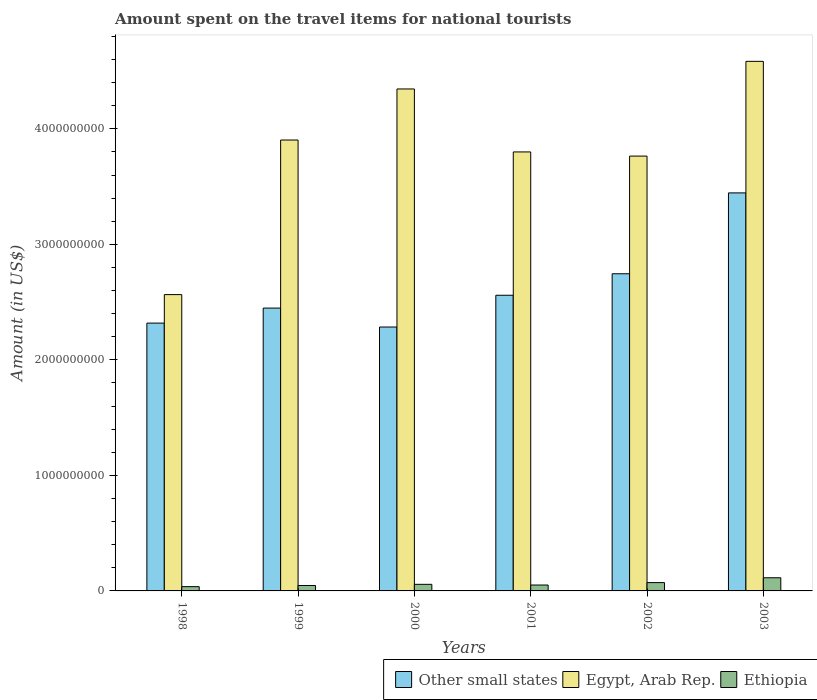Are the number of bars per tick equal to the number of legend labels?
Make the answer very short. Yes. Are the number of bars on each tick of the X-axis equal?
Offer a very short reply. Yes. How many bars are there on the 2nd tick from the left?
Ensure brevity in your answer.  3. How many bars are there on the 4th tick from the right?
Ensure brevity in your answer.  3. In how many cases, is the number of bars for a given year not equal to the number of legend labels?
Keep it short and to the point. 0. What is the amount spent on the travel items for national tourists in Egypt, Arab Rep. in 2001?
Provide a succinct answer. 3.80e+09. Across all years, what is the maximum amount spent on the travel items for national tourists in Other small states?
Your response must be concise. 3.45e+09. Across all years, what is the minimum amount spent on the travel items for national tourists in Other small states?
Your response must be concise. 2.28e+09. In which year was the amount spent on the travel items for national tourists in Ethiopia maximum?
Provide a short and direct response. 2003. In which year was the amount spent on the travel items for national tourists in Other small states minimum?
Your answer should be compact. 2000. What is the total amount spent on the travel items for national tourists in Other small states in the graph?
Keep it short and to the point. 1.58e+1. What is the difference between the amount spent on the travel items for national tourists in Ethiopia in 1999 and that in 2000?
Your answer should be compact. -1.00e+07. What is the difference between the amount spent on the travel items for national tourists in Ethiopia in 2000 and the amount spent on the travel items for national tourists in Egypt, Arab Rep. in 2002?
Keep it short and to the point. -3.71e+09. What is the average amount spent on the travel items for national tourists in Other small states per year?
Give a very brief answer. 2.63e+09. In the year 2003, what is the difference between the amount spent on the travel items for national tourists in Ethiopia and amount spent on the travel items for national tourists in Other small states?
Your answer should be compact. -3.33e+09. What is the ratio of the amount spent on the travel items for national tourists in Other small states in 2000 to that in 2003?
Provide a succinct answer. 0.66. Is the difference between the amount spent on the travel items for national tourists in Ethiopia in 1998 and 2002 greater than the difference between the amount spent on the travel items for national tourists in Other small states in 1998 and 2002?
Give a very brief answer. Yes. What is the difference between the highest and the second highest amount spent on the travel items for national tourists in Egypt, Arab Rep.?
Offer a terse response. 2.39e+08. What is the difference between the highest and the lowest amount spent on the travel items for national tourists in Egypt, Arab Rep.?
Give a very brief answer. 2.02e+09. In how many years, is the amount spent on the travel items for national tourists in Ethiopia greater than the average amount spent on the travel items for national tourists in Ethiopia taken over all years?
Keep it short and to the point. 2. What does the 2nd bar from the left in 1998 represents?
Your response must be concise. Egypt, Arab Rep. What does the 1st bar from the right in 1998 represents?
Give a very brief answer. Ethiopia. Is it the case that in every year, the sum of the amount spent on the travel items for national tourists in Ethiopia and amount spent on the travel items for national tourists in Other small states is greater than the amount spent on the travel items for national tourists in Egypt, Arab Rep.?
Offer a very short reply. No. How many legend labels are there?
Provide a short and direct response. 3. What is the title of the graph?
Ensure brevity in your answer.  Amount spent on the travel items for national tourists. What is the Amount (in US$) in Other small states in 1998?
Provide a short and direct response. 2.32e+09. What is the Amount (in US$) in Egypt, Arab Rep. in 1998?
Keep it short and to the point. 2.56e+09. What is the Amount (in US$) in Ethiopia in 1998?
Your response must be concise. 3.70e+07. What is the Amount (in US$) in Other small states in 1999?
Ensure brevity in your answer.  2.45e+09. What is the Amount (in US$) in Egypt, Arab Rep. in 1999?
Ensure brevity in your answer.  3.90e+09. What is the Amount (in US$) in Ethiopia in 1999?
Your response must be concise. 4.70e+07. What is the Amount (in US$) in Other small states in 2000?
Offer a very short reply. 2.28e+09. What is the Amount (in US$) in Egypt, Arab Rep. in 2000?
Your answer should be very brief. 4.34e+09. What is the Amount (in US$) in Ethiopia in 2000?
Give a very brief answer. 5.70e+07. What is the Amount (in US$) in Other small states in 2001?
Ensure brevity in your answer.  2.56e+09. What is the Amount (in US$) in Egypt, Arab Rep. in 2001?
Make the answer very short. 3.80e+09. What is the Amount (in US$) in Ethiopia in 2001?
Ensure brevity in your answer.  5.10e+07. What is the Amount (in US$) in Other small states in 2002?
Your answer should be very brief. 2.75e+09. What is the Amount (in US$) of Egypt, Arab Rep. in 2002?
Offer a terse response. 3.76e+09. What is the Amount (in US$) of Ethiopia in 2002?
Your answer should be very brief. 7.20e+07. What is the Amount (in US$) in Other small states in 2003?
Your answer should be very brief. 3.45e+09. What is the Amount (in US$) of Egypt, Arab Rep. in 2003?
Make the answer very short. 4.58e+09. What is the Amount (in US$) in Ethiopia in 2003?
Ensure brevity in your answer.  1.14e+08. Across all years, what is the maximum Amount (in US$) in Other small states?
Give a very brief answer. 3.45e+09. Across all years, what is the maximum Amount (in US$) of Egypt, Arab Rep.?
Your answer should be very brief. 4.58e+09. Across all years, what is the maximum Amount (in US$) in Ethiopia?
Offer a very short reply. 1.14e+08. Across all years, what is the minimum Amount (in US$) of Other small states?
Your answer should be compact. 2.28e+09. Across all years, what is the minimum Amount (in US$) of Egypt, Arab Rep.?
Make the answer very short. 2.56e+09. Across all years, what is the minimum Amount (in US$) of Ethiopia?
Your answer should be compact. 3.70e+07. What is the total Amount (in US$) in Other small states in the graph?
Give a very brief answer. 1.58e+1. What is the total Amount (in US$) of Egypt, Arab Rep. in the graph?
Offer a terse response. 2.30e+1. What is the total Amount (in US$) of Ethiopia in the graph?
Offer a very short reply. 3.78e+08. What is the difference between the Amount (in US$) in Other small states in 1998 and that in 1999?
Your response must be concise. -1.30e+08. What is the difference between the Amount (in US$) of Egypt, Arab Rep. in 1998 and that in 1999?
Your answer should be compact. -1.34e+09. What is the difference between the Amount (in US$) of Ethiopia in 1998 and that in 1999?
Provide a succinct answer. -1.00e+07. What is the difference between the Amount (in US$) of Other small states in 1998 and that in 2000?
Your answer should be compact. 3.41e+07. What is the difference between the Amount (in US$) in Egypt, Arab Rep. in 1998 and that in 2000?
Your answer should be very brief. -1.78e+09. What is the difference between the Amount (in US$) of Ethiopia in 1998 and that in 2000?
Your answer should be compact. -2.00e+07. What is the difference between the Amount (in US$) in Other small states in 1998 and that in 2001?
Your answer should be compact. -2.41e+08. What is the difference between the Amount (in US$) of Egypt, Arab Rep. in 1998 and that in 2001?
Offer a very short reply. -1.24e+09. What is the difference between the Amount (in US$) of Ethiopia in 1998 and that in 2001?
Ensure brevity in your answer.  -1.40e+07. What is the difference between the Amount (in US$) in Other small states in 1998 and that in 2002?
Your answer should be very brief. -4.27e+08. What is the difference between the Amount (in US$) of Egypt, Arab Rep. in 1998 and that in 2002?
Make the answer very short. -1.20e+09. What is the difference between the Amount (in US$) of Ethiopia in 1998 and that in 2002?
Offer a very short reply. -3.50e+07. What is the difference between the Amount (in US$) of Other small states in 1998 and that in 2003?
Give a very brief answer. -1.13e+09. What is the difference between the Amount (in US$) of Egypt, Arab Rep. in 1998 and that in 2003?
Your response must be concise. -2.02e+09. What is the difference between the Amount (in US$) in Ethiopia in 1998 and that in 2003?
Ensure brevity in your answer.  -7.70e+07. What is the difference between the Amount (in US$) in Other small states in 1999 and that in 2000?
Your response must be concise. 1.64e+08. What is the difference between the Amount (in US$) of Egypt, Arab Rep. in 1999 and that in 2000?
Offer a terse response. -4.42e+08. What is the difference between the Amount (in US$) in Ethiopia in 1999 and that in 2000?
Offer a very short reply. -1.00e+07. What is the difference between the Amount (in US$) of Other small states in 1999 and that in 2001?
Your answer should be compact. -1.11e+08. What is the difference between the Amount (in US$) of Egypt, Arab Rep. in 1999 and that in 2001?
Make the answer very short. 1.03e+08. What is the difference between the Amount (in US$) of Other small states in 1999 and that in 2002?
Your answer should be very brief. -2.97e+08. What is the difference between the Amount (in US$) in Egypt, Arab Rep. in 1999 and that in 2002?
Make the answer very short. 1.39e+08. What is the difference between the Amount (in US$) in Ethiopia in 1999 and that in 2002?
Provide a short and direct response. -2.50e+07. What is the difference between the Amount (in US$) of Other small states in 1999 and that in 2003?
Make the answer very short. -9.97e+08. What is the difference between the Amount (in US$) in Egypt, Arab Rep. in 1999 and that in 2003?
Provide a short and direct response. -6.81e+08. What is the difference between the Amount (in US$) in Ethiopia in 1999 and that in 2003?
Offer a terse response. -6.70e+07. What is the difference between the Amount (in US$) in Other small states in 2000 and that in 2001?
Offer a very short reply. -2.75e+08. What is the difference between the Amount (in US$) of Egypt, Arab Rep. in 2000 and that in 2001?
Provide a short and direct response. 5.45e+08. What is the difference between the Amount (in US$) of Ethiopia in 2000 and that in 2001?
Make the answer very short. 6.00e+06. What is the difference between the Amount (in US$) of Other small states in 2000 and that in 2002?
Make the answer very short. -4.61e+08. What is the difference between the Amount (in US$) of Egypt, Arab Rep. in 2000 and that in 2002?
Your answer should be very brief. 5.81e+08. What is the difference between the Amount (in US$) of Ethiopia in 2000 and that in 2002?
Ensure brevity in your answer.  -1.50e+07. What is the difference between the Amount (in US$) in Other small states in 2000 and that in 2003?
Ensure brevity in your answer.  -1.16e+09. What is the difference between the Amount (in US$) of Egypt, Arab Rep. in 2000 and that in 2003?
Provide a short and direct response. -2.39e+08. What is the difference between the Amount (in US$) of Ethiopia in 2000 and that in 2003?
Offer a very short reply. -5.70e+07. What is the difference between the Amount (in US$) in Other small states in 2001 and that in 2002?
Your answer should be very brief. -1.86e+08. What is the difference between the Amount (in US$) in Egypt, Arab Rep. in 2001 and that in 2002?
Your answer should be compact. 3.60e+07. What is the difference between the Amount (in US$) in Ethiopia in 2001 and that in 2002?
Your answer should be compact. -2.10e+07. What is the difference between the Amount (in US$) in Other small states in 2001 and that in 2003?
Provide a succinct answer. -8.86e+08. What is the difference between the Amount (in US$) of Egypt, Arab Rep. in 2001 and that in 2003?
Make the answer very short. -7.84e+08. What is the difference between the Amount (in US$) of Ethiopia in 2001 and that in 2003?
Offer a terse response. -6.30e+07. What is the difference between the Amount (in US$) of Other small states in 2002 and that in 2003?
Ensure brevity in your answer.  -7.00e+08. What is the difference between the Amount (in US$) in Egypt, Arab Rep. in 2002 and that in 2003?
Make the answer very short. -8.20e+08. What is the difference between the Amount (in US$) in Ethiopia in 2002 and that in 2003?
Your response must be concise. -4.20e+07. What is the difference between the Amount (in US$) in Other small states in 1998 and the Amount (in US$) in Egypt, Arab Rep. in 1999?
Offer a very short reply. -1.58e+09. What is the difference between the Amount (in US$) in Other small states in 1998 and the Amount (in US$) in Ethiopia in 1999?
Give a very brief answer. 2.27e+09. What is the difference between the Amount (in US$) in Egypt, Arab Rep. in 1998 and the Amount (in US$) in Ethiopia in 1999?
Your answer should be very brief. 2.52e+09. What is the difference between the Amount (in US$) in Other small states in 1998 and the Amount (in US$) in Egypt, Arab Rep. in 2000?
Your answer should be compact. -2.03e+09. What is the difference between the Amount (in US$) in Other small states in 1998 and the Amount (in US$) in Ethiopia in 2000?
Your response must be concise. 2.26e+09. What is the difference between the Amount (in US$) in Egypt, Arab Rep. in 1998 and the Amount (in US$) in Ethiopia in 2000?
Keep it short and to the point. 2.51e+09. What is the difference between the Amount (in US$) in Other small states in 1998 and the Amount (in US$) in Egypt, Arab Rep. in 2001?
Provide a succinct answer. -1.48e+09. What is the difference between the Amount (in US$) in Other small states in 1998 and the Amount (in US$) in Ethiopia in 2001?
Offer a terse response. 2.27e+09. What is the difference between the Amount (in US$) of Egypt, Arab Rep. in 1998 and the Amount (in US$) of Ethiopia in 2001?
Give a very brief answer. 2.51e+09. What is the difference between the Amount (in US$) of Other small states in 1998 and the Amount (in US$) of Egypt, Arab Rep. in 2002?
Give a very brief answer. -1.45e+09. What is the difference between the Amount (in US$) in Other small states in 1998 and the Amount (in US$) in Ethiopia in 2002?
Your answer should be compact. 2.25e+09. What is the difference between the Amount (in US$) in Egypt, Arab Rep. in 1998 and the Amount (in US$) in Ethiopia in 2002?
Your response must be concise. 2.49e+09. What is the difference between the Amount (in US$) of Other small states in 1998 and the Amount (in US$) of Egypt, Arab Rep. in 2003?
Ensure brevity in your answer.  -2.27e+09. What is the difference between the Amount (in US$) in Other small states in 1998 and the Amount (in US$) in Ethiopia in 2003?
Provide a succinct answer. 2.20e+09. What is the difference between the Amount (in US$) of Egypt, Arab Rep. in 1998 and the Amount (in US$) of Ethiopia in 2003?
Your answer should be very brief. 2.45e+09. What is the difference between the Amount (in US$) in Other small states in 1999 and the Amount (in US$) in Egypt, Arab Rep. in 2000?
Ensure brevity in your answer.  -1.90e+09. What is the difference between the Amount (in US$) of Other small states in 1999 and the Amount (in US$) of Ethiopia in 2000?
Ensure brevity in your answer.  2.39e+09. What is the difference between the Amount (in US$) of Egypt, Arab Rep. in 1999 and the Amount (in US$) of Ethiopia in 2000?
Offer a terse response. 3.85e+09. What is the difference between the Amount (in US$) of Other small states in 1999 and the Amount (in US$) of Egypt, Arab Rep. in 2001?
Make the answer very short. -1.35e+09. What is the difference between the Amount (in US$) in Other small states in 1999 and the Amount (in US$) in Ethiopia in 2001?
Provide a short and direct response. 2.40e+09. What is the difference between the Amount (in US$) of Egypt, Arab Rep. in 1999 and the Amount (in US$) of Ethiopia in 2001?
Provide a short and direct response. 3.85e+09. What is the difference between the Amount (in US$) in Other small states in 1999 and the Amount (in US$) in Egypt, Arab Rep. in 2002?
Your answer should be very brief. -1.32e+09. What is the difference between the Amount (in US$) of Other small states in 1999 and the Amount (in US$) of Ethiopia in 2002?
Ensure brevity in your answer.  2.38e+09. What is the difference between the Amount (in US$) of Egypt, Arab Rep. in 1999 and the Amount (in US$) of Ethiopia in 2002?
Provide a short and direct response. 3.83e+09. What is the difference between the Amount (in US$) in Other small states in 1999 and the Amount (in US$) in Egypt, Arab Rep. in 2003?
Give a very brief answer. -2.14e+09. What is the difference between the Amount (in US$) in Other small states in 1999 and the Amount (in US$) in Ethiopia in 2003?
Your answer should be very brief. 2.33e+09. What is the difference between the Amount (in US$) of Egypt, Arab Rep. in 1999 and the Amount (in US$) of Ethiopia in 2003?
Provide a succinct answer. 3.79e+09. What is the difference between the Amount (in US$) of Other small states in 2000 and the Amount (in US$) of Egypt, Arab Rep. in 2001?
Provide a short and direct response. -1.52e+09. What is the difference between the Amount (in US$) in Other small states in 2000 and the Amount (in US$) in Ethiopia in 2001?
Provide a succinct answer. 2.23e+09. What is the difference between the Amount (in US$) in Egypt, Arab Rep. in 2000 and the Amount (in US$) in Ethiopia in 2001?
Provide a short and direct response. 4.29e+09. What is the difference between the Amount (in US$) in Other small states in 2000 and the Amount (in US$) in Egypt, Arab Rep. in 2002?
Keep it short and to the point. -1.48e+09. What is the difference between the Amount (in US$) of Other small states in 2000 and the Amount (in US$) of Ethiopia in 2002?
Ensure brevity in your answer.  2.21e+09. What is the difference between the Amount (in US$) of Egypt, Arab Rep. in 2000 and the Amount (in US$) of Ethiopia in 2002?
Your answer should be very brief. 4.27e+09. What is the difference between the Amount (in US$) of Other small states in 2000 and the Amount (in US$) of Egypt, Arab Rep. in 2003?
Keep it short and to the point. -2.30e+09. What is the difference between the Amount (in US$) of Other small states in 2000 and the Amount (in US$) of Ethiopia in 2003?
Provide a short and direct response. 2.17e+09. What is the difference between the Amount (in US$) of Egypt, Arab Rep. in 2000 and the Amount (in US$) of Ethiopia in 2003?
Keep it short and to the point. 4.23e+09. What is the difference between the Amount (in US$) of Other small states in 2001 and the Amount (in US$) of Egypt, Arab Rep. in 2002?
Your response must be concise. -1.20e+09. What is the difference between the Amount (in US$) of Other small states in 2001 and the Amount (in US$) of Ethiopia in 2002?
Provide a succinct answer. 2.49e+09. What is the difference between the Amount (in US$) of Egypt, Arab Rep. in 2001 and the Amount (in US$) of Ethiopia in 2002?
Offer a terse response. 3.73e+09. What is the difference between the Amount (in US$) in Other small states in 2001 and the Amount (in US$) in Egypt, Arab Rep. in 2003?
Your response must be concise. -2.02e+09. What is the difference between the Amount (in US$) in Other small states in 2001 and the Amount (in US$) in Ethiopia in 2003?
Give a very brief answer. 2.45e+09. What is the difference between the Amount (in US$) of Egypt, Arab Rep. in 2001 and the Amount (in US$) of Ethiopia in 2003?
Offer a very short reply. 3.69e+09. What is the difference between the Amount (in US$) in Other small states in 2002 and the Amount (in US$) in Egypt, Arab Rep. in 2003?
Provide a succinct answer. -1.84e+09. What is the difference between the Amount (in US$) of Other small states in 2002 and the Amount (in US$) of Ethiopia in 2003?
Provide a succinct answer. 2.63e+09. What is the difference between the Amount (in US$) in Egypt, Arab Rep. in 2002 and the Amount (in US$) in Ethiopia in 2003?
Your answer should be very brief. 3.65e+09. What is the average Amount (in US$) in Other small states per year?
Provide a short and direct response. 2.63e+09. What is the average Amount (in US$) in Egypt, Arab Rep. per year?
Give a very brief answer. 3.83e+09. What is the average Amount (in US$) of Ethiopia per year?
Your answer should be compact. 6.30e+07. In the year 1998, what is the difference between the Amount (in US$) of Other small states and Amount (in US$) of Egypt, Arab Rep.?
Keep it short and to the point. -2.47e+08. In the year 1998, what is the difference between the Amount (in US$) of Other small states and Amount (in US$) of Ethiopia?
Ensure brevity in your answer.  2.28e+09. In the year 1998, what is the difference between the Amount (in US$) of Egypt, Arab Rep. and Amount (in US$) of Ethiopia?
Provide a succinct answer. 2.53e+09. In the year 1999, what is the difference between the Amount (in US$) of Other small states and Amount (in US$) of Egypt, Arab Rep.?
Give a very brief answer. -1.45e+09. In the year 1999, what is the difference between the Amount (in US$) in Other small states and Amount (in US$) in Ethiopia?
Offer a terse response. 2.40e+09. In the year 1999, what is the difference between the Amount (in US$) of Egypt, Arab Rep. and Amount (in US$) of Ethiopia?
Your response must be concise. 3.86e+09. In the year 2000, what is the difference between the Amount (in US$) of Other small states and Amount (in US$) of Egypt, Arab Rep.?
Ensure brevity in your answer.  -2.06e+09. In the year 2000, what is the difference between the Amount (in US$) in Other small states and Amount (in US$) in Ethiopia?
Your answer should be compact. 2.23e+09. In the year 2000, what is the difference between the Amount (in US$) of Egypt, Arab Rep. and Amount (in US$) of Ethiopia?
Keep it short and to the point. 4.29e+09. In the year 2001, what is the difference between the Amount (in US$) of Other small states and Amount (in US$) of Egypt, Arab Rep.?
Give a very brief answer. -1.24e+09. In the year 2001, what is the difference between the Amount (in US$) in Other small states and Amount (in US$) in Ethiopia?
Make the answer very short. 2.51e+09. In the year 2001, what is the difference between the Amount (in US$) in Egypt, Arab Rep. and Amount (in US$) in Ethiopia?
Give a very brief answer. 3.75e+09. In the year 2002, what is the difference between the Amount (in US$) of Other small states and Amount (in US$) of Egypt, Arab Rep.?
Offer a terse response. -1.02e+09. In the year 2002, what is the difference between the Amount (in US$) in Other small states and Amount (in US$) in Ethiopia?
Your answer should be very brief. 2.67e+09. In the year 2002, what is the difference between the Amount (in US$) of Egypt, Arab Rep. and Amount (in US$) of Ethiopia?
Offer a terse response. 3.69e+09. In the year 2003, what is the difference between the Amount (in US$) in Other small states and Amount (in US$) in Egypt, Arab Rep.?
Keep it short and to the point. -1.14e+09. In the year 2003, what is the difference between the Amount (in US$) of Other small states and Amount (in US$) of Ethiopia?
Offer a very short reply. 3.33e+09. In the year 2003, what is the difference between the Amount (in US$) of Egypt, Arab Rep. and Amount (in US$) of Ethiopia?
Provide a succinct answer. 4.47e+09. What is the ratio of the Amount (in US$) of Other small states in 1998 to that in 1999?
Offer a very short reply. 0.95. What is the ratio of the Amount (in US$) of Egypt, Arab Rep. in 1998 to that in 1999?
Your response must be concise. 0.66. What is the ratio of the Amount (in US$) in Ethiopia in 1998 to that in 1999?
Make the answer very short. 0.79. What is the ratio of the Amount (in US$) in Other small states in 1998 to that in 2000?
Offer a terse response. 1.01. What is the ratio of the Amount (in US$) in Egypt, Arab Rep. in 1998 to that in 2000?
Keep it short and to the point. 0.59. What is the ratio of the Amount (in US$) in Ethiopia in 1998 to that in 2000?
Provide a succinct answer. 0.65. What is the ratio of the Amount (in US$) in Other small states in 1998 to that in 2001?
Keep it short and to the point. 0.91. What is the ratio of the Amount (in US$) of Egypt, Arab Rep. in 1998 to that in 2001?
Offer a terse response. 0.68. What is the ratio of the Amount (in US$) of Ethiopia in 1998 to that in 2001?
Provide a short and direct response. 0.73. What is the ratio of the Amount (in US$) of Other small states in 1998 to that in 2002?
Keep it short and to the point. 0.84. What is the ratio of the Amount (in US$) in Egypt, Arab Rep. in 1998 to that in 2002?
Provide a short and direct response. 0.68. What is the ratio of the Amount (in US$) of Ethiopia in 1998 to that in 2002?
Your answer should be very brief. 0.51. What is the ratio of the Amount (in US$) of Other small states in 1998 to that in 2003?
Provide a short and direct response. 0.67. What is the ratio of the Amount (in US$) of Egypt, Arab Rep. in 1998 to that in 2003?
Keep it short and to the point. 0.56. What is the ratio of the Amount (in US$) in Ethiopia in 1998 to that in 2003?
Make the answer very short. 0.32. What is the ratio of the Amount (in US$) in Other small states in 1999 to that in 2000?
Keep it short and to the point. 1.07. What is the ratio of the Amount (in US$) of Egypt, Arab Rep. in 1999 to that in 2000?
Offer a very short reply. 0.9. What is the ratio of the Amount (in US$) in Ethiopia in 1999 to that in 2000?
Provide a short and direct response. 0.82. What is the ratio of the Amount (in US$) in Other small states in 1999 to that in 2001?
Your response must be concise. 0.96. What is the ratio of the Amount (in US$) of Egypt, Arab Rep. in 1999 to that in 2001?
Provide a succinct answer. 1.03. What is the ratio of the Amount (in US$) in Ethiopia in 1999 to that in 2001?
Your answer should be very brief. 0.92. What is the ratio of the Amount (in US$) of Other small states in 1999 to that in 2002?
Keep it short and to the point. 0.89. What is the ratio of the Amount (in US$) of Egypt, Arab Rep. in 1999 to that in 2002?
Keep it short and to the point. 1.04. What is the ratio of the Amount (in US$) of Ethiopia in 1999 to that in 2002?
Provide a short and direct response. 0.65. What is the ratio of the Amount (in US$) in Other small states in 1999 to that in 2003?
Give a very brief answer. 0.71. What is the ratio of the Amount (in US$) of Egypt, Arab Rep. in 1999 to that in 2003?
Offer a very short reply. 0.85. What is the ratio of the Amount (in US$) of Ethiopia in 1999 to that in 2003?
Offer a very short reply. 0.41. What is the ratio of the Amount (in US$) in Other small states in 2000 to that in 2001?
Your response must be concise. 0.89. What is the ratio of the Amount (in US$) of Egypt, Arab Rep. in 2000 to that in 2001?
Provide a succinct answer. 1.14. What is the ratio of the Amount (in US$) in Ethiopia in 2000 to that in 2001?
Your response must be concise. 1.12. What is the ratio of the Amount (in US$) in Other small states in 2000 to that in 2002?
Make the answer very short. 0.83. What is the ratio of the Amount (in US$) in Egypt, Arab Rep. in 2000 to that in 2002?
Keep it short and to the point. 1.15. What is the ratio of the Amount (in US$) in Ethiopia in 2000 to that in 2002?
Provide a short and direct response. 0.79. What is the ratio of the Amount (in US$) of Other small states in 2000 to that in 2003?
Your answer should be compact. 0.66. What is the ratio of the Amount (in US$) in Egypt, Arab Rep. in 2000 to that in 2003?
Your answer should be compact. 0.95. What is the ratio of the Amount (in US$) in Other small states in 2001 to that in 2002?
Your response must be concise. 0.93. What is the ratio of the Amount (in US$) of Egypt, Arab Rep. in 2001 to that in 2002?
Offer a terse response. 1.01. What is the ratio of the Amount (in US$) of Ethiopia in 2001 to that in 2002?
Provide a succinct answer. 0.71. What is the ratio of the Amount (in US$) in Other small states in 2001 to that in 2003?
Keep it short and to the point. 0.74. What is the ratio of the Amount (in US$) in Egypt, Arab Rep. in 2001 to that in 2003?
Your answer should be compact. 0.83. What is the ratio of the Amount (in US$) in Ethiopia in 2001 to that in 2003?
Provide a short and direct response. 0.45. What is the ratio of the Amount (in US$) in Other small states in 2002 to that in 2003?
Provide a succinct answer. 0.8. What is the ratio of the Amount (in US$) of Egypt, Arab Rep. in 2002 to that in 2003?
Your answer should be compact. 0.82. What is the ratio of the Amount (in US$) in Ethiopia in 2002 to that in 2003?
Your answer should be very brief. 0.63. What is the difference between the highest and the second highest Amount (in US$) of Other small states?
Your response must be concise. 7.00e+08. What is the difference between the highest and the second highest Amount (in US$) in Egypt, Arab Rep.?
Ensure brevity in your answer.  2.39e+08. What is the difference between the highest and the second highest Amount (in US$) in Ethiopia?
Your answer should be compact. 4.20e+07. What is the difference between the highest and the lowest Amount (in US$) of Other small states?
Provide a short and direct response. 1.16e+09. What is the difference between the highest and the lowest Amount (in US$) in Egypt, Arab Rep.?
Ensure brevity in your answer.  2.02e+09. What is the difference between the highest and the lowest Amount (in US$) of Ethiopia?
Your response must be concise. 7.70e+07. 